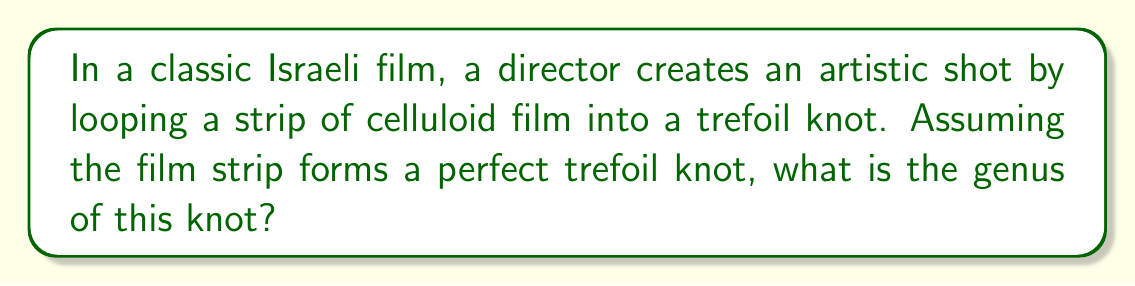Could you help me with this problem? To determine the genus of the trefoil knot formed by the celluloid film, we need to follow these steps:

1. Recall that the genus of a knot is the minimum number of holes in a surface that the knot can be embedded on without self-intersection.

2. For the trefoil knot, we can use the following formula to calculate its genus:

   $$g = \frac{c - n + 1}{2}$$

   Where:
   $g$ is the genus
   $c$ is the crossing number
   $n$ is the number of components (for a knot, always 1)

3. The trefoil knot has a crossing number of 3.

4. Substituting these values into the formula:

   $$g = \frac{3 - 1 + 1}{2} = \frac{3}{2} = 1$$

5. The genus must be an integer, so we confirm that the genus of the trefoil knot is 1.

This means that the looped celluloid film forming a trefoil knot can be embedded on a surface with one hole (like a torus) without self-intersection.
Answer: 1 